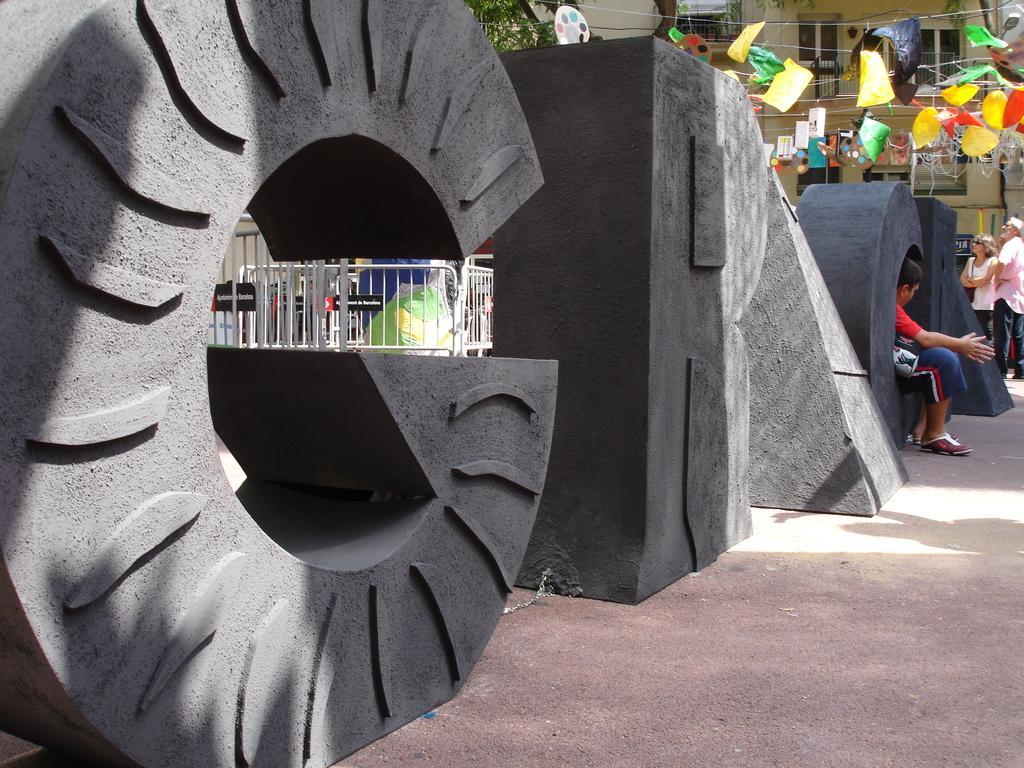Describe this image in one or two sentences. This picture shows couple of buildings and a tree and we see people standing and few color papers and we see a metal fence and alphabets made with concrete on the sidewalk. 